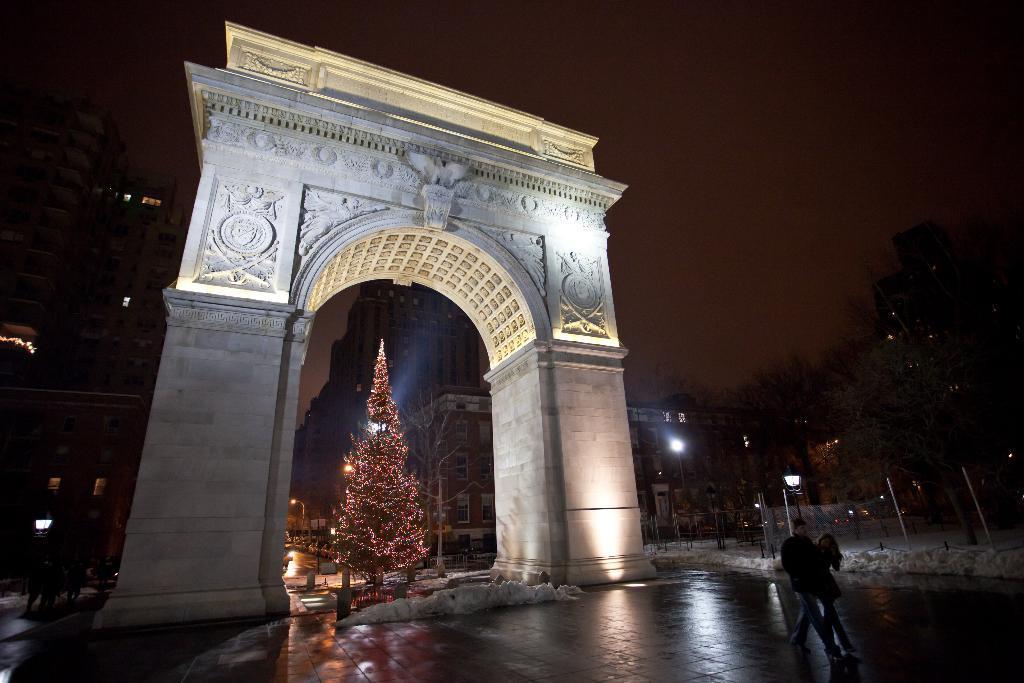Could you give a brief overview of what you see in this image? In this image I can see two people standing on the road. To the back of these people I can see the tree and the arch. In the background there are many buildings, lights, trees and the sky. 